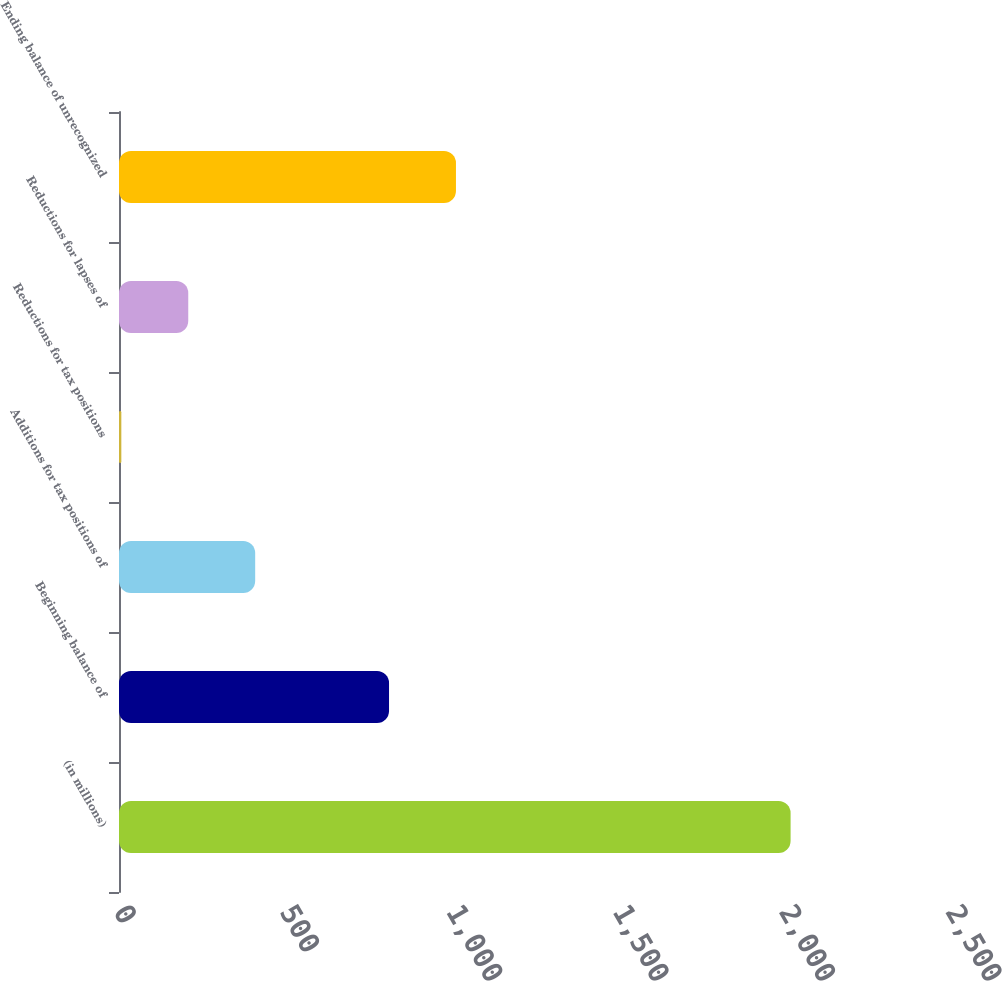Convert chart. <chart><loc_0><loc_0><loc_500><loc_500><bar_chart><fcel>(in millions)<fcel>Beginning balance of<fcel>Additions for tax positions of<fcel>Reductions for tax positions<fcel>Reductions for lapses of<fcel>Ending balance of unrecognized<nl><fcel>2018<fcel>811.4<fcel>409.2<fcel>7<fcel>208.1<fcel>1012.5<nl></chart> 